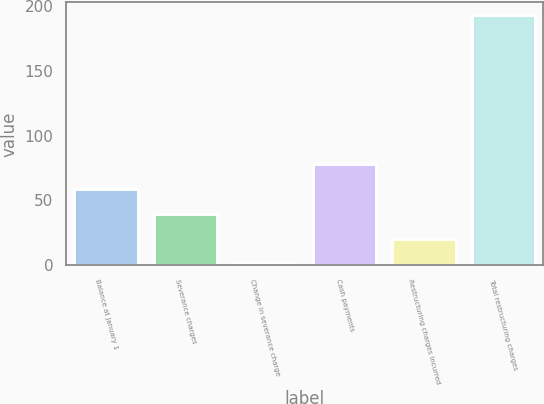Convert chart to OTSL. <chart><loc_0><loc_0><loc_500><loc_500><bar_chart><fcel>Balance at January 1<fcel>Severance charges<fcel>Change in severance charge<fcel>Cash payments<fcel>Restructuring charges incurred<fcel>Total restructuring charges<nl><fcel>58.6<fcel>39.4<fcel>1<fcel>77.8<fcel>20.2<fcel>193<nl></chart> 